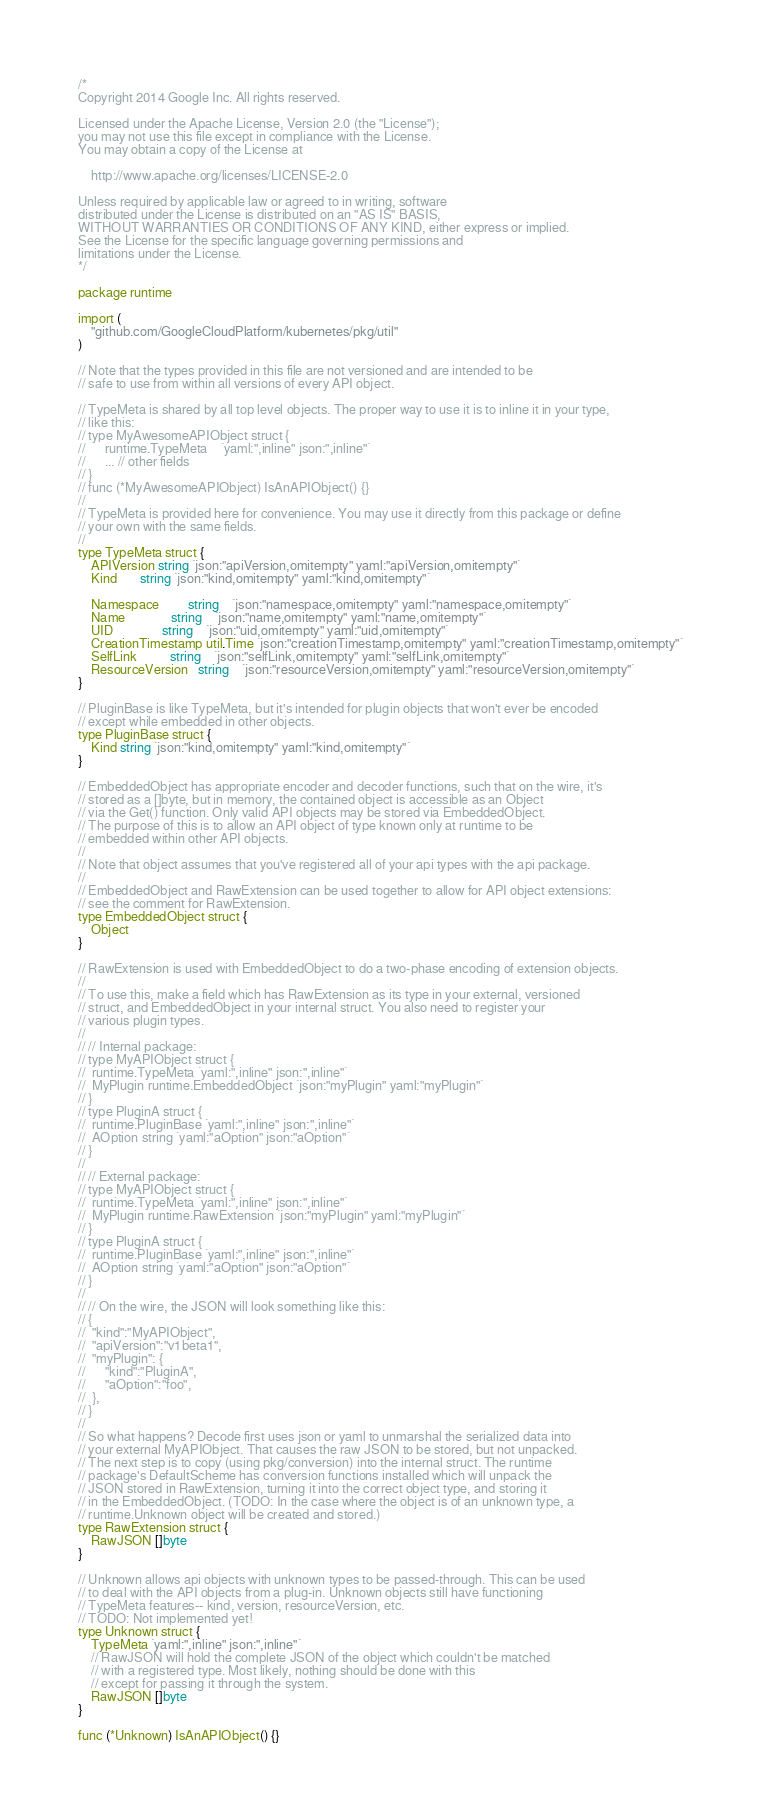<code> <loc_0><loc_0><loc_500><loc_500><_Go_>/*
Copyright 2014 Google Inc. All rights reserved.

Licensed under the Apache License, Version 2.0 (the "License");
you may not use this file except in compliance with the License.
You may obtain a copy of the License at

    http://www.apache.org/licenses/LICENSE-2.0

Unless required by applicable law or agreed to in writing, software
distributed under the License is distributed on an "AS IS" BASIS,
WITHOUT WARRANTIES OR CONDITIONS OF ANY KIND, either express or implied.
See the License for the specific language governing permissions and
limitations under the License.
*/

package runtime

import (
	"github.com/GoogleCloudPlatform/kubernetes/pkg/util"
)

// Note that the types provided in this file are not versioned and are intended to be
// safe to use from within all versions of every API object.

// TypeMeta is shared by all top level objects. The proper way to use it is to inline it in your type,
// like this:
// type MyAwesomeAPIObject struct {
//      runtime.TypeMeta    `yaml:",inline" json:",inline"`
//      ... // other fields
// }
// func (*MyAwesomeAPIObject) IsAnAPIObject() {}
//
// TypeMeta is provided here for convenience. You may use it directly from this package or define
// your own with the same fields.
//
type TypeMeta struct {
	APIVersion string `json:"apiVersion,omitempty" yaml:"apiVersion,omitempty"`
	Kind       string `json:"kind,omitempty" yaml:"kind,omitempty"`

	Namespace         string    `json:"namespace,omitempty" yaml:"namespace,omitempty"`
	Name              string    `json:"name,omitempty" yaml:"name,omitempty"`
	UID               string    `json:"uid,omitempty" yaml:"uid,omitempty"`
	CreationTimestamp util.Time `json:"creationTimestamp,omitempty" yaml:"creationTimestamp,omitempty"`
	SelfLink          string    `json:"selfLink,omitempty" yaml:"selfLink,omitempty"`
	ResourceVersion   string    `json:"resourceVersion,omitempty" yaml:"resourceVersion,omitempty"`
}

// PluginBase is like TypeMeta, but it's intended for plugin objects that won't ever be encoded
// except while embedded in other objects.
type PluginBase struct {
	Kind string `json:"kind,omitempty" yaml:"kind,omitempty"`
}

// EmbeddedObject has appropriate encoder and decoder functions, such that on the wire, it's
// stored as a []byte, but in memory, the contained object is accessible as an Object
// via the Get() function. Only valid API objects may be stored via EmbeddedObject.
// The purpose of this is to allow an API object of type known only at runtime to be
// embedded within other API objects.
//
// Note that object assumes that you've registered all of your api types with the api package.
//
// EmbeddedObject and RawExtension can be used together to allow for API object extensions:
// see the comment for RawExtension.
type EmbeddedObject struct {
	Object
}

// RawExtension is used with EmbeddedObject to do a two-phase encoding of extension objects.
//
// To use this, make a field which has RawExtension as its type in your external, versioned
// struct, and EmbeddedObject in your internal struct. You also need to register your
// various plugin types.
//
// // Internal package:
// type MyAPIObject struct {
// 	runtime.TypeMeta `yaml:",inline" json:",inline"`
//	MyPlugin runtime.EmbeddedObject `json:"myPlugin" yaml:"myPlugin"`
// }
// type PluginA struct {
// 	runtime.PluginBase `yaml:",inline" json:",inline"`
//	AOption string `yaml:"aOption" json:"aOption"`
// }
//
// // External package:
// type MyAPIObject struct {
// 	runtime.TypeMeta `yaml:",inline" json:",inline"`
//	MyPlugin runtime.RawExtension `json:"myPlugin" yaml:"myPlugin"`
// }
// type PluginA struct {
// 	runtime.PluginBase `yaml:",inline" json:",inline"`
//	AOption string `yaml:"aOption" json:"aOption"`
// }
//
// // On the wire, the JSON will look something like this:
// {
//	"kind":"MyAPIObject",
//	"apiVersion":"v1beta1",
//	"myPlugin": {
//		"kind":"PluginA",
//		"aOption":"foo",
//	},
// }
//
// So what happens? Decode first uses json or yaml to unmarshal the serialized data into
// your external MyAPIObject. That causes the raw JSON to be stored, but not unpacked.
// The next step is to copy (using pkg/conversion) into the internal struct. The runtime
// package's DefaultScheme has conversion functions installed which will unpack the
// JSON stored in RawExtension, turning it into the correct object type, and storing it
// in the EmbeddedObject. (TODO: In the case where the object is of an unknown type, a
// runtime.Unknown object will be created and stored.)
type RawExtension struct {
	RawJSON []byte
}

// Unknown allows api objects with unknown types to be passed-through. This can be used
// to deal with the API objects from a plug-in. Unknown objects still have functioning
// TypeMeta features-- kind, version, resourceVersion, etc.
// TODO: Not implemented yet!
type Unknown struct {
	TypeMeta `yaml:",inline" json:",inline"`
	// RawJSON will hold the complete JSON of the object which couldn't be matched
	// with a registered type. Most likely, nothing should be done with this
	// except for passing it through the system.
	RawJSON []byte
}

func (*Unknown) IsAnAPIObject() {}
</code> 